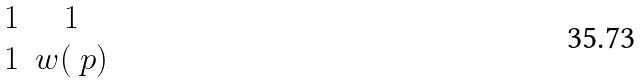<formula> <loc_0><loc_0><loc_500><loc_500>\begin{matrix} 1 & 1 \\ 1 & w ( \ p ) \end{matrix}</formula> 